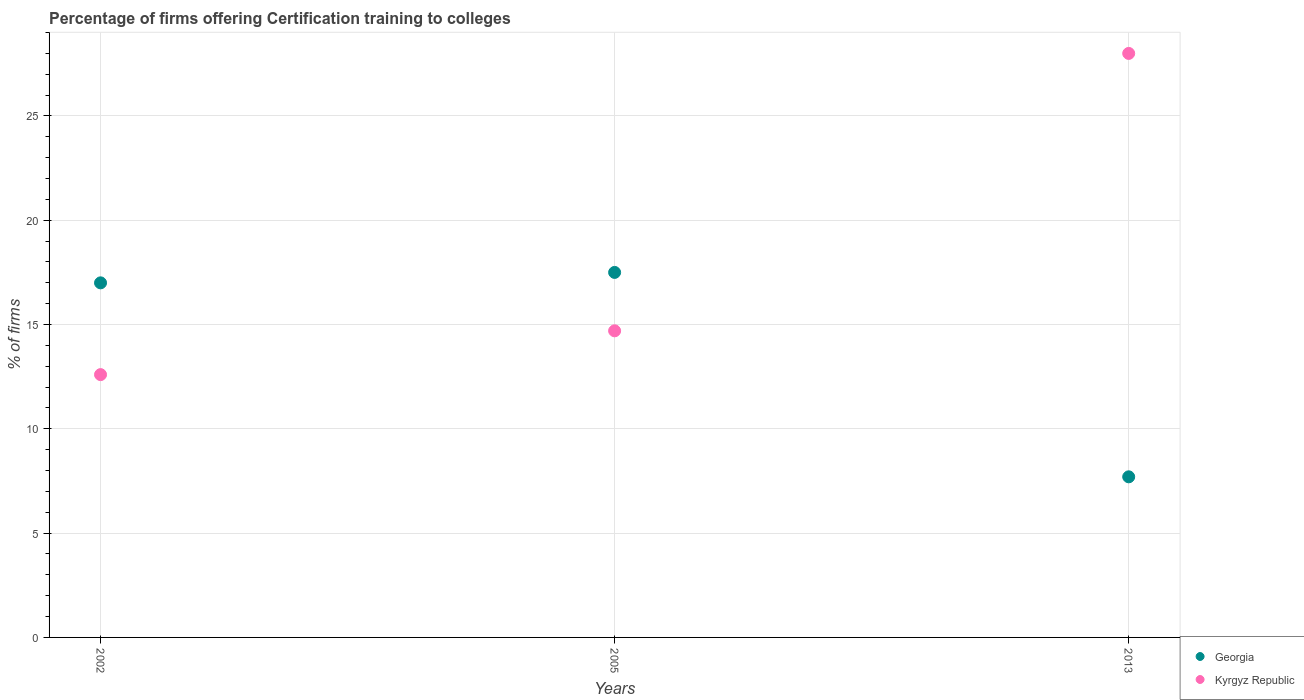How many different coloured dotlines are there?
Your answer should be compact. 2. Is the number of dotlines equal to the number of legend labels?
Make the answer very short. Yes. Across all years, what is the minimum percentage of firms offering certification training to colleges in Kyrgyz Republic?
Offer a very short reply. 12.6. In which year was the percentage of firms offering certification training to colleges in Kyrgyz Republic maximum?
Ensure brevity in your answer.  2013. What is the total percentage of firms offering certification training to colleges in Georgia in the graph?
Provide a succinct answer. 42.2. What is the difference between the percentage of firms offering certification training to colleges in Georgia in 2002 and that in 2013?
Provide a succinct answer. 9.3. What is the difference between the percentage of firms offering certification training to colleges in Kyrgyz Republic in 2013 and the percentage of firms offering certification training to colleges in Georgia in 2005?
Provide a short and direct response. 10.5. What is the average percentage of firms offering certification training to colleges in Georgia per year?
Make the answer very short. 14.07. In the year 2013, what is the difference between the percentage of firms offering certification training to colleges in Georgia and percentage of firms offering certification training to colleges in Kyrgyz Republic?
Keep it short and to the point. -20.3. What is the ratio of the percentage of firms offering certification training to colleges in Georgia in 2002 to that in 2013?
Your answer should be compact. 2.21. Is the percentage of firms offering certification training to colleges in Georgia in 2005 less than that in 2013?
Your response must be concise. No. What is the difference between the highest and the second highest percentage of firms offering certification training to colleges in Kyrgyz Republic?
Your answer should be very brief. 13.3. In how many years, is the percentage of firms offering certification training to colleges in Kyrgyz Republic greater than the average percentage of firms offering certification training to colleges in Kyrgyz Republic taken over all years?
Provide a succinct answer. 1. Is the sum of the percentage of firms offering certification training to colleges in Georgia in 2002 and 2005 greater than the maximum percentage of firms offering certification training to colleges in Kyrgyz Republic across all years?
Ensure brevity in your answer.  Yes. Does the percentage of firms offering certification training to colleges in Kyrgyz Republic monotonically increase over the years?
Keep it short and to the point. Yes. Is the percentage of firms offering certification training to colleges in Georgia strictly greater than the percentage of firms offering certification training to colleges in Kyrgyz Republic over the years?
Make the answer very short. No. Is the percentage of firms offering certification training to colleges in Kyrgyz Republic strictly less than the percentage of firms offering certification training to colleges in Georgia over the years?
Your response must be concise. No. Does the graph contain any zero values?
Your response must be concise. No. Does the graph contain grids?
Provide a short and direct response. Yes. How are the legend labels stacked?
Give a very brief answer. Vertical. What is the title of the graph?
Make the answer very short. Percentage of firms offering Certification training to colleges. Does "Greenland" appear as one of the legend labels in the graph?
Make the answer very short. No. What is the label or title of the Y-axis?
Your answer should be very brief. % of firms. What is the % of firms in Kyrgyz Republic in 2005?
Ensure brevity in your answer.  14.7. What is the % of firms of Kyrgyz Republic in 2013?
Your answer should be very brief. 28. Across all years, what is the maximum % of firms in Kyrgyz Republic?
Provide a succinct answer. 28. Across all years, what is the minimum % of firms of Georgia?
Make the answer very short. 7.7. Across all years, what is the minimum % of firms of Kyrgyz Republic?
Your answer should be compact. 12.6. What is the total % of firms of Georgia in the graph?
Keep it short and to the point. 42.2. What is the total % of firms in Kyrgyz Republic in the graph?
Make the answer very short. 55.3. What is the difference between the % of firms in Kyrgyz Republic in 2002 and that in 2005?
Offer a very short reply. -2.1. What is the difference between the % of firms of Kyrgyz Republic in 2002 and that in 2013?
Give a very brief answer. -15.4. What is the difference between the % of firms in Georgia in 2002 and the % of firms in Kyrgyz Republic in 2005?
Keep it short and to the point. 2.3. What is the difference between the % of firms in Georgia in 2002 and the % of firms in Kyrgyz Republic in 2013?
Make the answer very short. -11. What is the average % of firms in Georgia per year?
Keep it short and to the point. 14.07. What is the average % of firms in Kyrgyz Republic per year?
Your answer should be very brief. 18.43. In the year 2002, what is the difference between the % of firms of Georgia and % of firms of Kyrgyz Republic?
Your answer should be very brief. 4.4. In the year 2013, what is the difference between the % of firms in Georgia and % of firms in Kyrgyz Republic?
Provide a succinct answer. -20.3. What is the ratio of the % of firms in Georgia in 2002 to that in 2005?
Provide a short and direct response. 0.97. What is the ratio of the % of firms in Georgia in 2002 to that in 2013?
Your answer should be compact. 2.21. What is the ratio of the % of firms in Kyrgyz Republic in 2002 to that in 2013?
Offer a terse response. 0.45. What is the ratio of the % of firms of Georgia in 2005 to that in 2013?
Your answer should be compact. 2.27. What is the ratio of the % of firms in Kyrgyz Republic in 2005 to that in 2013?
Provide a succinct answer. 0.53. What is the difference between the highest and the second highest % of firms of Georgia?
Keep it short and to the point. 0.5. What is the difference between the highest and the second highest % of firms in Kyrgyz Republic?
Keep it short and to the point. 13.3. What is the difference between the highest and the lowest % of firms in Georgia?
Offer a very short reply. 9.8. What is the difference between the highest and the lowest % of firms of Kyrgyz Republic?
Offer a terse response. 15.4. 